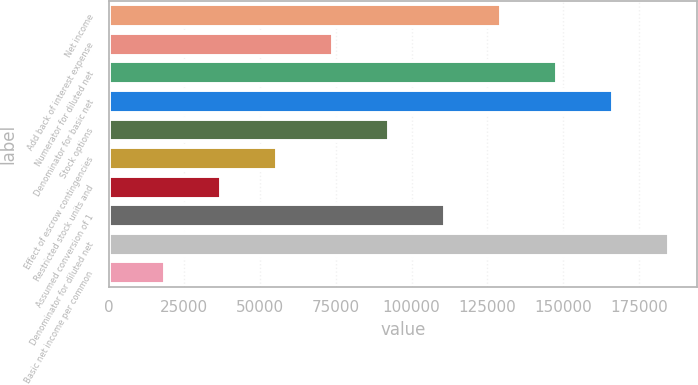<chart> <loc_0><loc_0><loc_500><loc_500><bar_chart><fcel>Net income<fcel>Add back of interest expense<fcel>Numerator for diluted net<fcel>Denominator for basic net<fcel>Stock options<fcel>Effect of escrow contingencies<fcel>Restricted stock units and<fcel>Assumed conversion of 1<fcel>Denominator for diluted net<fcel>Basic net income per common<nl><fcel>129566<fcel>74037.9<fcel>148075<fcel>166585<fcel>92547.3<fcel>55528.6<fcel>37019.2<fcel>111057<fcel>185094<fcel>18509.9<nl></chart> 